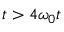<formula> <loc_0><loc_0><loc_500><loc_500>t > 4 \omega _ { 0 } t</formula> 